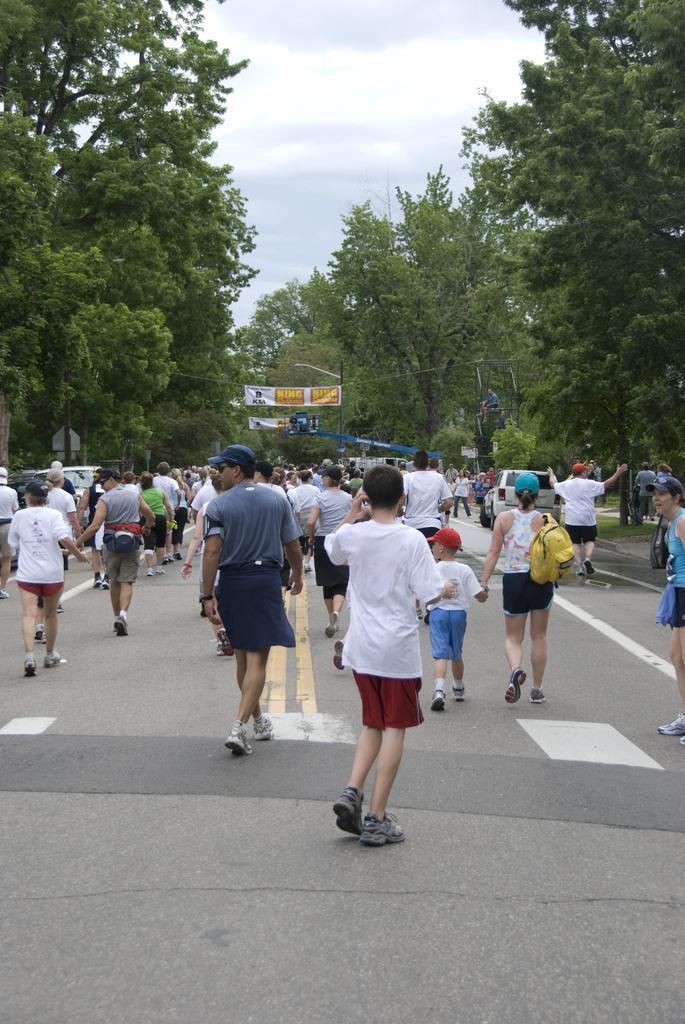Describe this image in one or two sentences. In this picture I see few people walking and a woman wore a cap and a bag on the back and few of them wore caps on their heads and I can see few trees and a couple of banners and a cloudy Sky. 